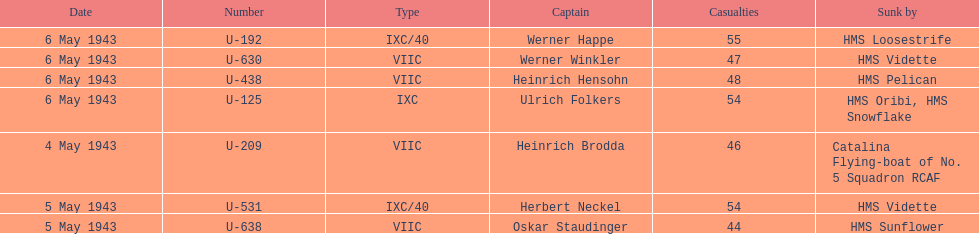Who are all of the captains? Heinrich Brodda, Oskar Staudinger, Herbert Neckel, Werner Happe, Ulrich Folkers, Werner Winkler, Heinrich Hensohn. What sunk each of the captains? Catalina Flying-boat of No. 5 Squadron RCAF, HMS Sunflower, HMS Vidette, HMS Loosestrife, HMS Oribi, HMS Snowflake, HMS Vidette, HMS Pelican. Which was sunk by the hms pelican? Heinrich Hensohn. 